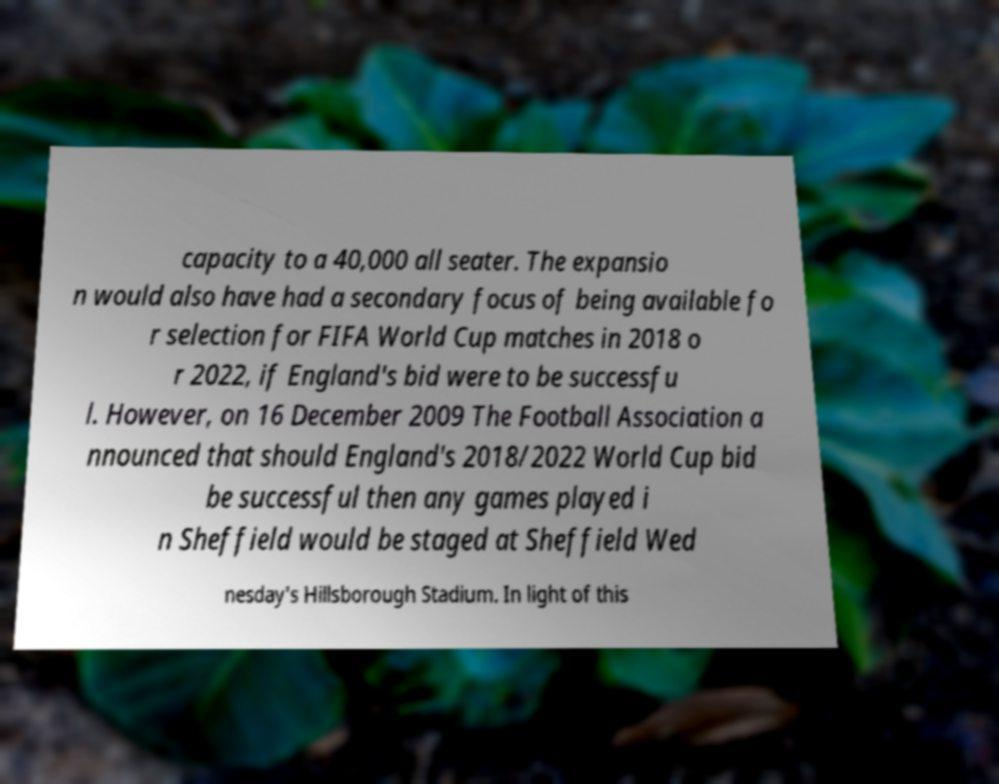Can you accurately transcribe the text from the provided image for me? capacity to a 40,000 all seater. The expansio n would also have had a secondary focus of being available fo r selection for FIFA World Cup matches in 2018 o r 2022, if England's bid were to be successfu l. However, on 16 December 2009 The Football Association a nnounced that should England's 2018/2022 World Cup bid be successful then any games played i n Sheffield would be staged at Sheffield Wed nesday's Hillsborough Stadium. In light of this 